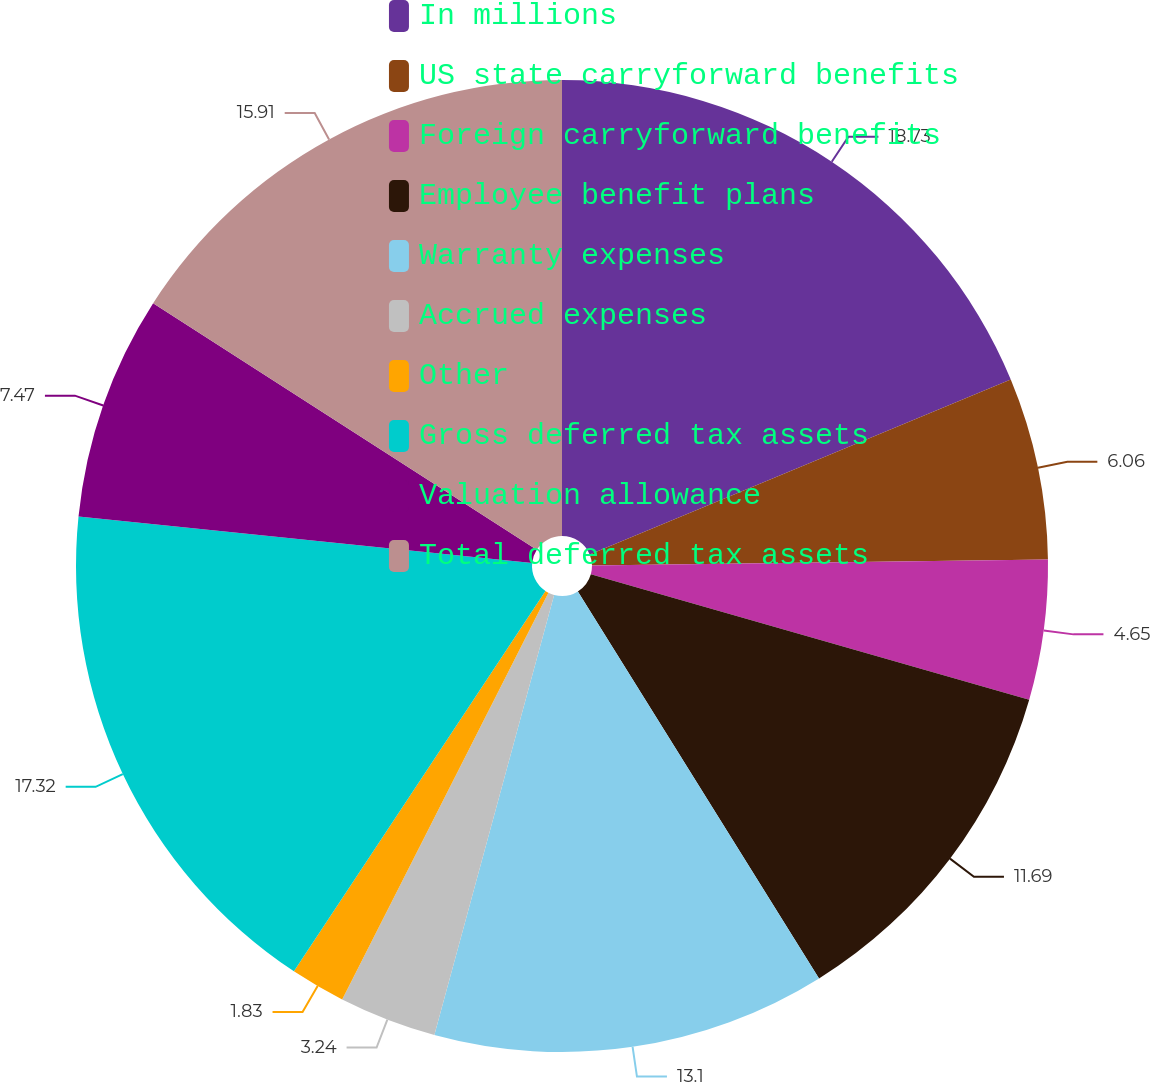Convert chart. <chart><loc_0><loc_0><loc_500><loc_500><pie_chart><fcel>In millions<fcel>US state carryforward benefits<fcel>Foreign carryforward benefits<fcel>Employee benefit plans<fcel>Warranty expenses<fcel>Accrued expenses<fcel>Other<fcel>Gross deferred tax assets<fcel>Valuation allowance<fcel>Total deferred tax assets<nl><fcel>18.73%<fcel>6.06%<fcel>4.65%<fcel>11.69%<fcel>13.1%<fcel>3.24%<fcel>1.83%<fcel>17.32%<fcel>7.47%<fcel>15.91%<nl></chart> 